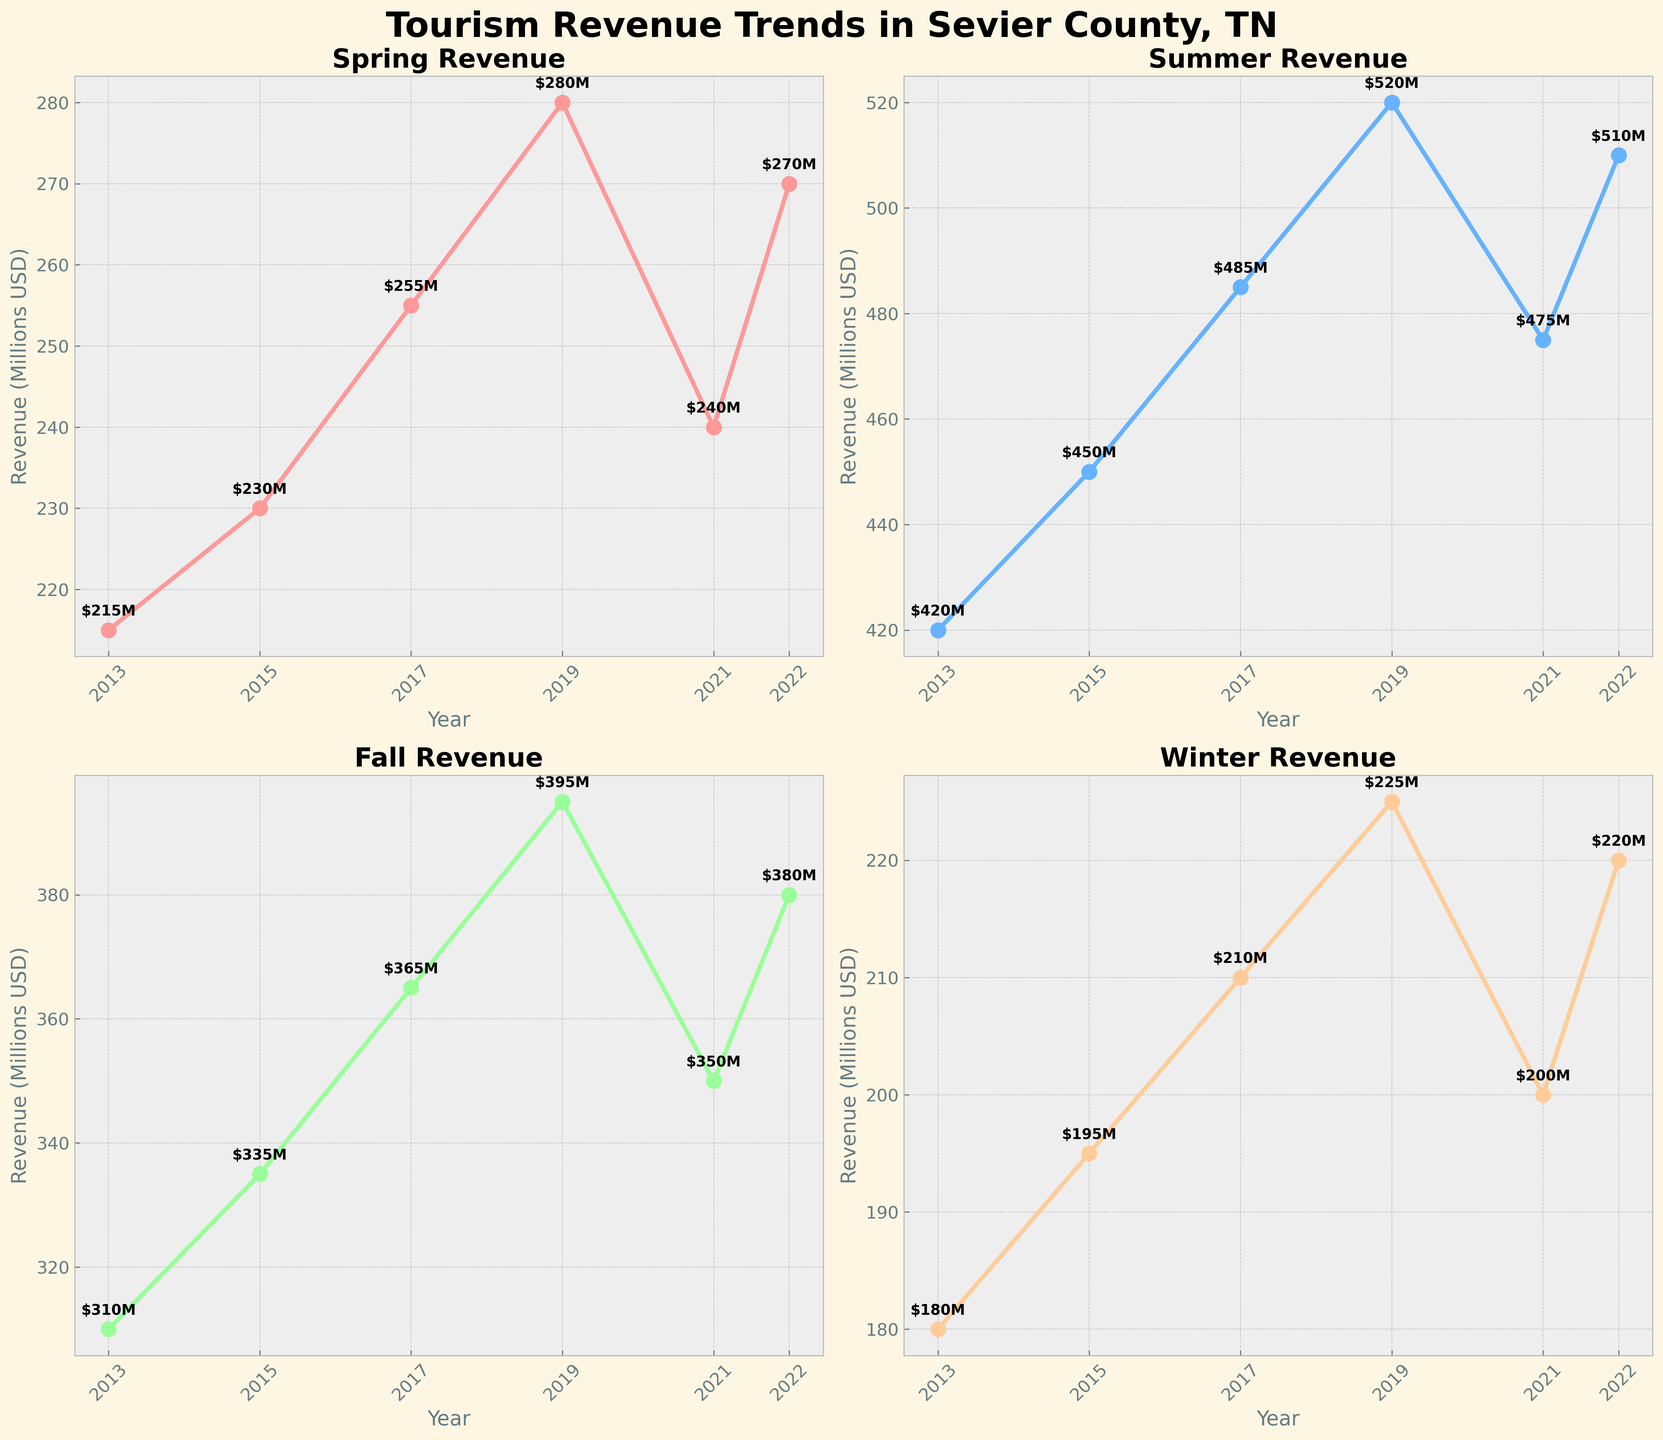What's the title of the figure? The title of the figure is displayed at the top-center of the entire plot. It is labeled as 'Tourism Revenue Trends in Sevier County, TN'.
Answer: Tourism Revenue Trends in Sevier County, TN Which season had the highest revenue in 2019? Look at the plot corresponding to each season in 2019 and identify which plot has the highest y-axis value in that year. According to the figure, the Summer season had the highest revenue in 2019 with $520M.
Answer: Summer How does Summer revenue in 2021 compare to Summer revenue in 2022? For comparison, look at the y-axis values for Summer revenue in both 2021 and 2022 in their respective subplots. Summer revenue in 2021 is $475M, while in 2022, it is $510M. Hence, Summer revenue increased in 2022 compared to 2021.
Answer: It increased What is the trend of Spring revenue from 2013 to 2022? By observing the Spring subplot, identify the trajectory of the data points from 2013 to 2022. The trend shows an overall increase from $215M in 2013 to $270M in 2022, with some fluctuations in between.
Answer: Increasing In which year did Fall revenue experience a significant jump, and by how much did it increase? Analyze the Fall subplot and look for a noticeable increase in revenue between consecutive years. From 2017 to 2019, Fall revenue increased from $365M to $395M, showing a significant jump of $30M.
Answer: 2019, by $30M Compare the Winter revenue in 2013 and 2022. By how much did it change? Check the Winter subplot and find the y-axis values for Winter revenue in 2013 and 2022. Winter revenue in 2013 is $180M, and in 2022, it is $220M. The change in revenue is $220M - $180M = $40M.
Answer: Increased by $40M What season saw the smallest revenues in 2015? Look at the subplots for each season in 2015, and identify the season with the lowest y-axis value. According to the plots, Winter had the smallest revenue in 2015 with $195M.
Answer: Winter How does the revenue for Spring in 2019 compare to that in Fall the same year? Refer to both the Spring and Fall subplots for the year 2019 and compare their y-axis values. Spring revenue is $280M, whereas Fall revenue is $395M in 2019. Hence, Fall revenue is higher than Spring revenue.
Answer: Fall revenue is higher Which season shows the most consistent growth over the years? Evaluate each subplot individually to determine which season's revenue has shown the most consistent upward trend. Winter shows a steady and consistent growth compared to other seasons, with a gradual increase each year.
Answer: Winter 